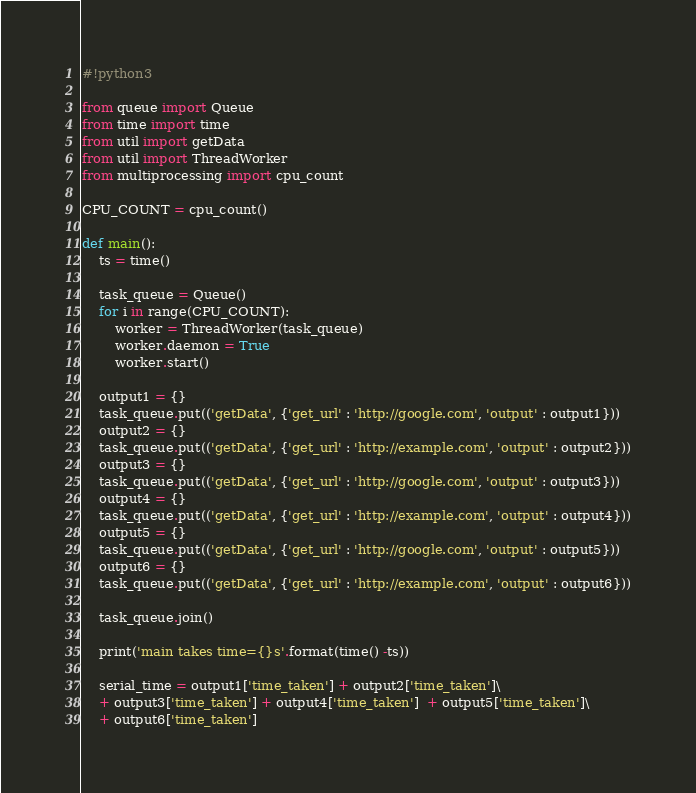<code> <loc_0><loc_0><loc_500><loc_500><_Python_>#!python3

from queue import Queue
from time import time
from util import getData
from util import ThreadWorker
from multiprocessing import cpu_count

CPU_COUNT = cpu_count()

def main():
    ts = time()

    task_queue = Queue()
    for i in range(CPU_COUNT):
        worker = ThreadWorker(task_queue)
        worker.daemon = True
        worker.start()

    output1 = {}
    task_queue.put(('getData', {'get_url' : 'http://google.com', 'output' : output1}))
    output2 = {}
    task_queue.put(('getData', {'get_url' : 'http://example.com', 'output' : output2}))
    output3 = {}
    task_queue.put(('getData', {'get_url' : 'http://google.com', 'output' : output3}))
    output4 = {}
    task_queue.put(('getData', {'get_url' : 'http://example.com', 'output' : output4}))
    output5 = {}
    task_queue.put(('getData', {'get_url' : 'http://google.com', 'output' : output5}))
    output6 = {}
    task_queue.put(('getData', {'get_url' : 'http://example.com', 'output' : output6}))

    task_queue.join()

    print('main takes time={}s'.format(time() -ts))

    serial_time = output1['time_taken'] + output2['time_taken']\
    + output3['time_taken'] + output4['time_taken']  + output5['time_taken']\
    + output6['time_taken']
</code> 